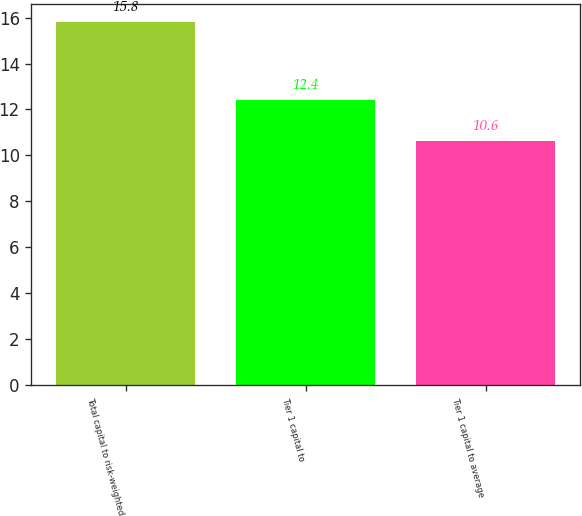<chart> <loc_0><loc_0><loc_500><loc_500><bar_chart><fcel>Total capital to risk-weighted<fcel>Tier 1 capital to<fcel>Tier 1 capital to average<nl><fcel>15.8<fcel>12.4<fcel>10.6<nl></chart> 